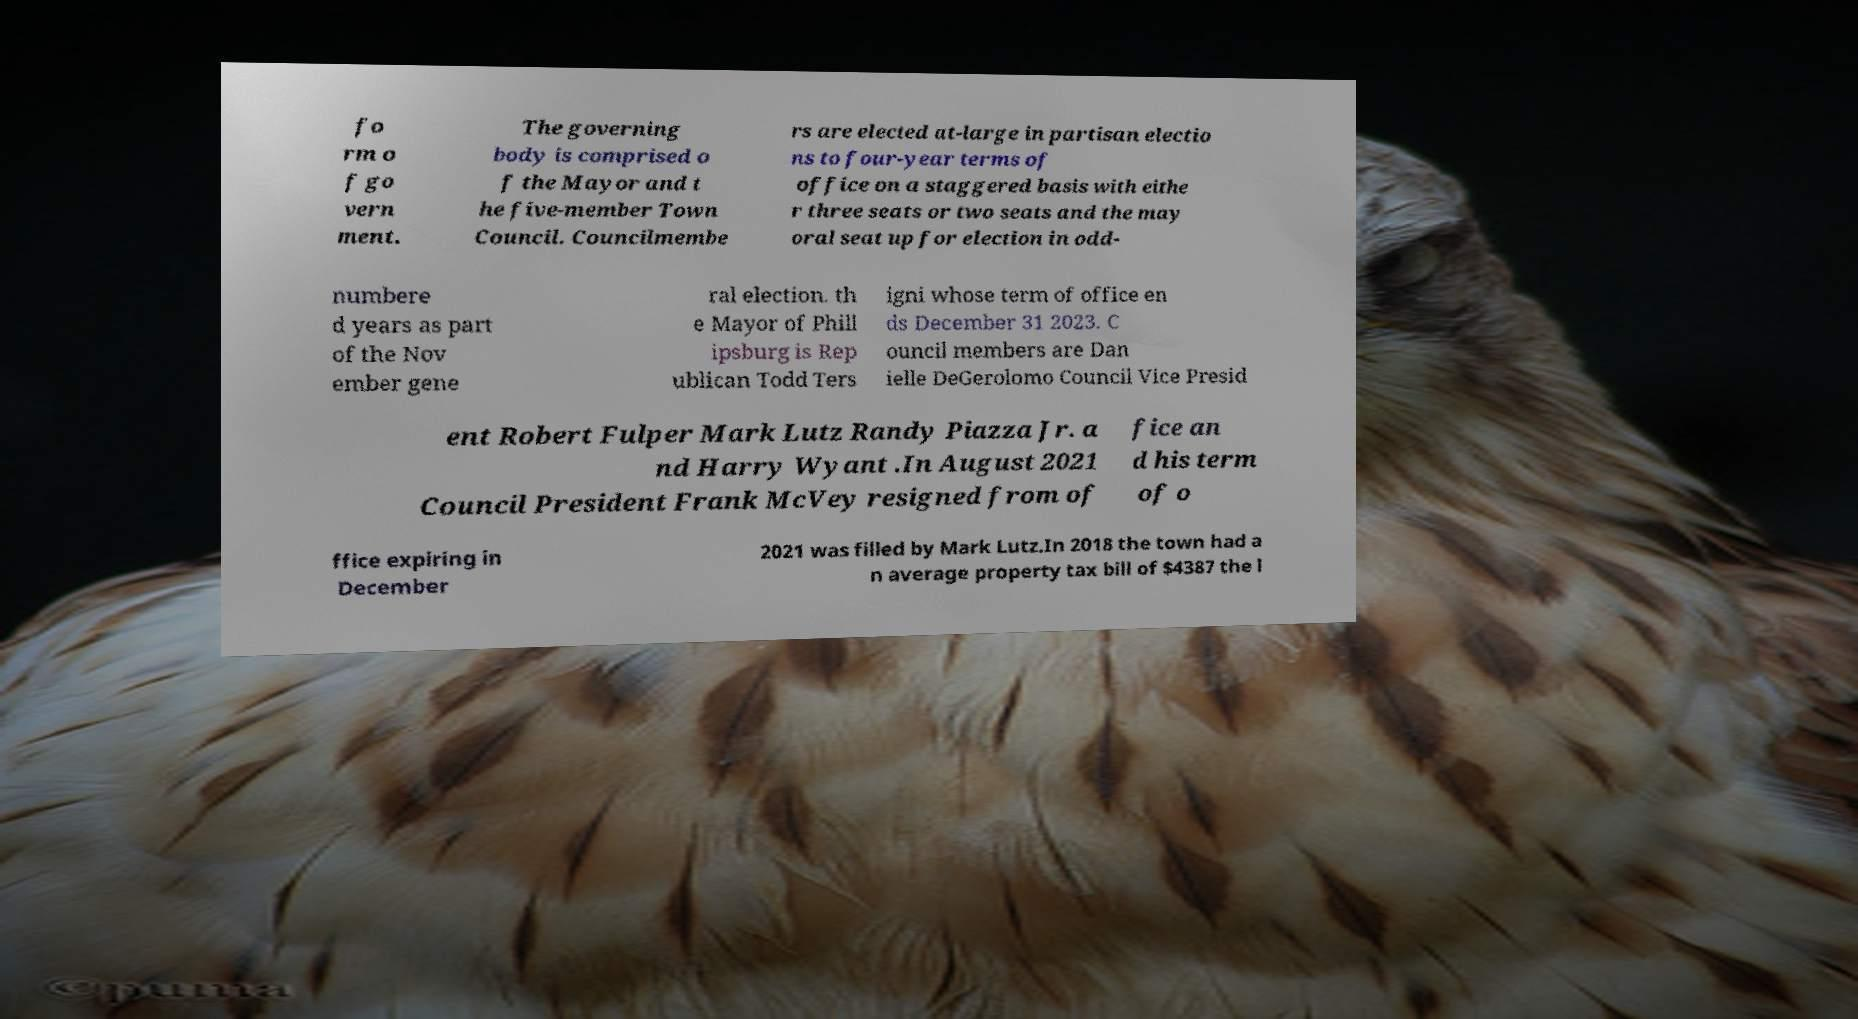Could you assist in decoding the text presented in this image and type it out clearly? fo rm o f go vern ment. The governing body is comprised o f the Mayor and t he five-member Town Council. Councilmembe rs are elected at-large in partisan electio ns to four-year terms of office on a staggered basis with eithe r three seats or two seats and the may oral seat up for election in odd- numbere d years as part of the Nov ember gene ral election. th e Mayor of Phill ipsburg is Rep ublican Todd Ters igni whose term of office en ds December 31 2023. C ouncil members are Dan ielle DeGerolomo Council Vice Presid ent Robert Fulper Mark Lutz Randy Piazza Jr. a nd Harry Wyant .In August 2021 Council President Frank McVey resigned from of fice an d his term of o ffice expiring in December 2021 was filled by Mark Lutz.In 2018 the town had a n average property tax bill of $4387 the l 